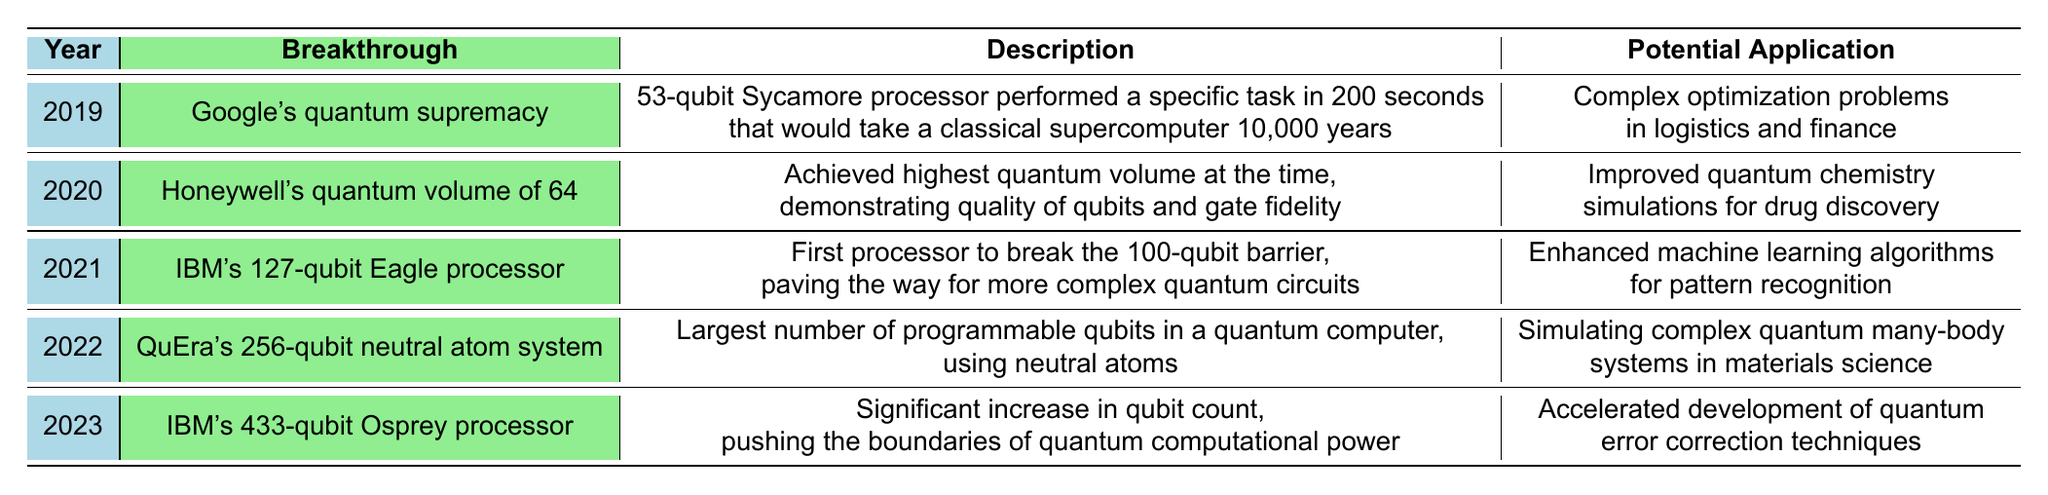What was the breakthrough achieved in 2020? The table lists the breakthroughs by year, and for 2020, it states "Honeywell's quantum volume of 64" as the breakthrough.
Answer: Honeywell's quantum volume of 64 Which breakthrough in quantum computing has the potential application of "accelerated development of quantum error correction techniques"? Looking at the table, the breakthrough listed for 2023 is "IBM's 433-qubit Osprey processor," which has this potential application.
Answer: IBM's 433-qubit Osprey processor How many qubits did IBM's Eagle processor have? The information in the table specifies that IBM's Eagle processor, which was a breakthrough in 2021, has 127 qubits.
Answer: 127 qubits What is the potential application of Google’s quantum supremacy breakthrough? Referring to the 2019 breakthrough, the potential application noted in the table is for complex optimization problems in logistics and finance.
Answer: Complex optimization problems in logistics and finance How many years did it take the quantum computer to perform a task compared to a classical supercomputer according to the 2019 breakthrough? The table indicates that Google's quantum processor completed a task in 200 seconds, which would take a classical supercomputer 10,000 years, so the difference is 10,000 years and 200 seconds.
Answer: 10,000 years What is the average number of qubits for the breakthroughs listed from 2019 to 2023? The qubits for the breakthroughs are 53, 64, 127, 256, and 433. Summing these gives 993 qubits. Dividing by 5 (the number of breakthroughs) yields an average of 199.6.
Answer: 199.6 qubits Is there a breakthrough that specifically mentions simulating complex quantum many-body systems? Checking the table, it shows that QuEra’s 256-qubit neutral atom system in 2022 has that specific potential application listed. Thus, the answer is yes.
Answer: Yes Which breakthrough has the largest number of qubits and what is its year? In the table, QuEra's 256-qubit neutral atom system from 2022 has the largest number of qubits; comparing it to all other breakthroughs, it is indeed the largest.
Answer: 2022, QuEra's 256-qubit neutral atom system Considering the potential applications listed, which field has a timeline of "already in use, expanding rapidly"? The table shows that quantum key distribution in the field of Cryptography is stated as already in use and expanding rapidly.
Answer: Cryptography Which breakthrough has increased the machine learning capabilities described in the table? The breakthrough mentioned for 2021 states it enhances machine learning algorithms for pattern recognition, which specifically refers to IBM's Eagle processor.
Answer: IBM's 127-qubit Eagle processor 